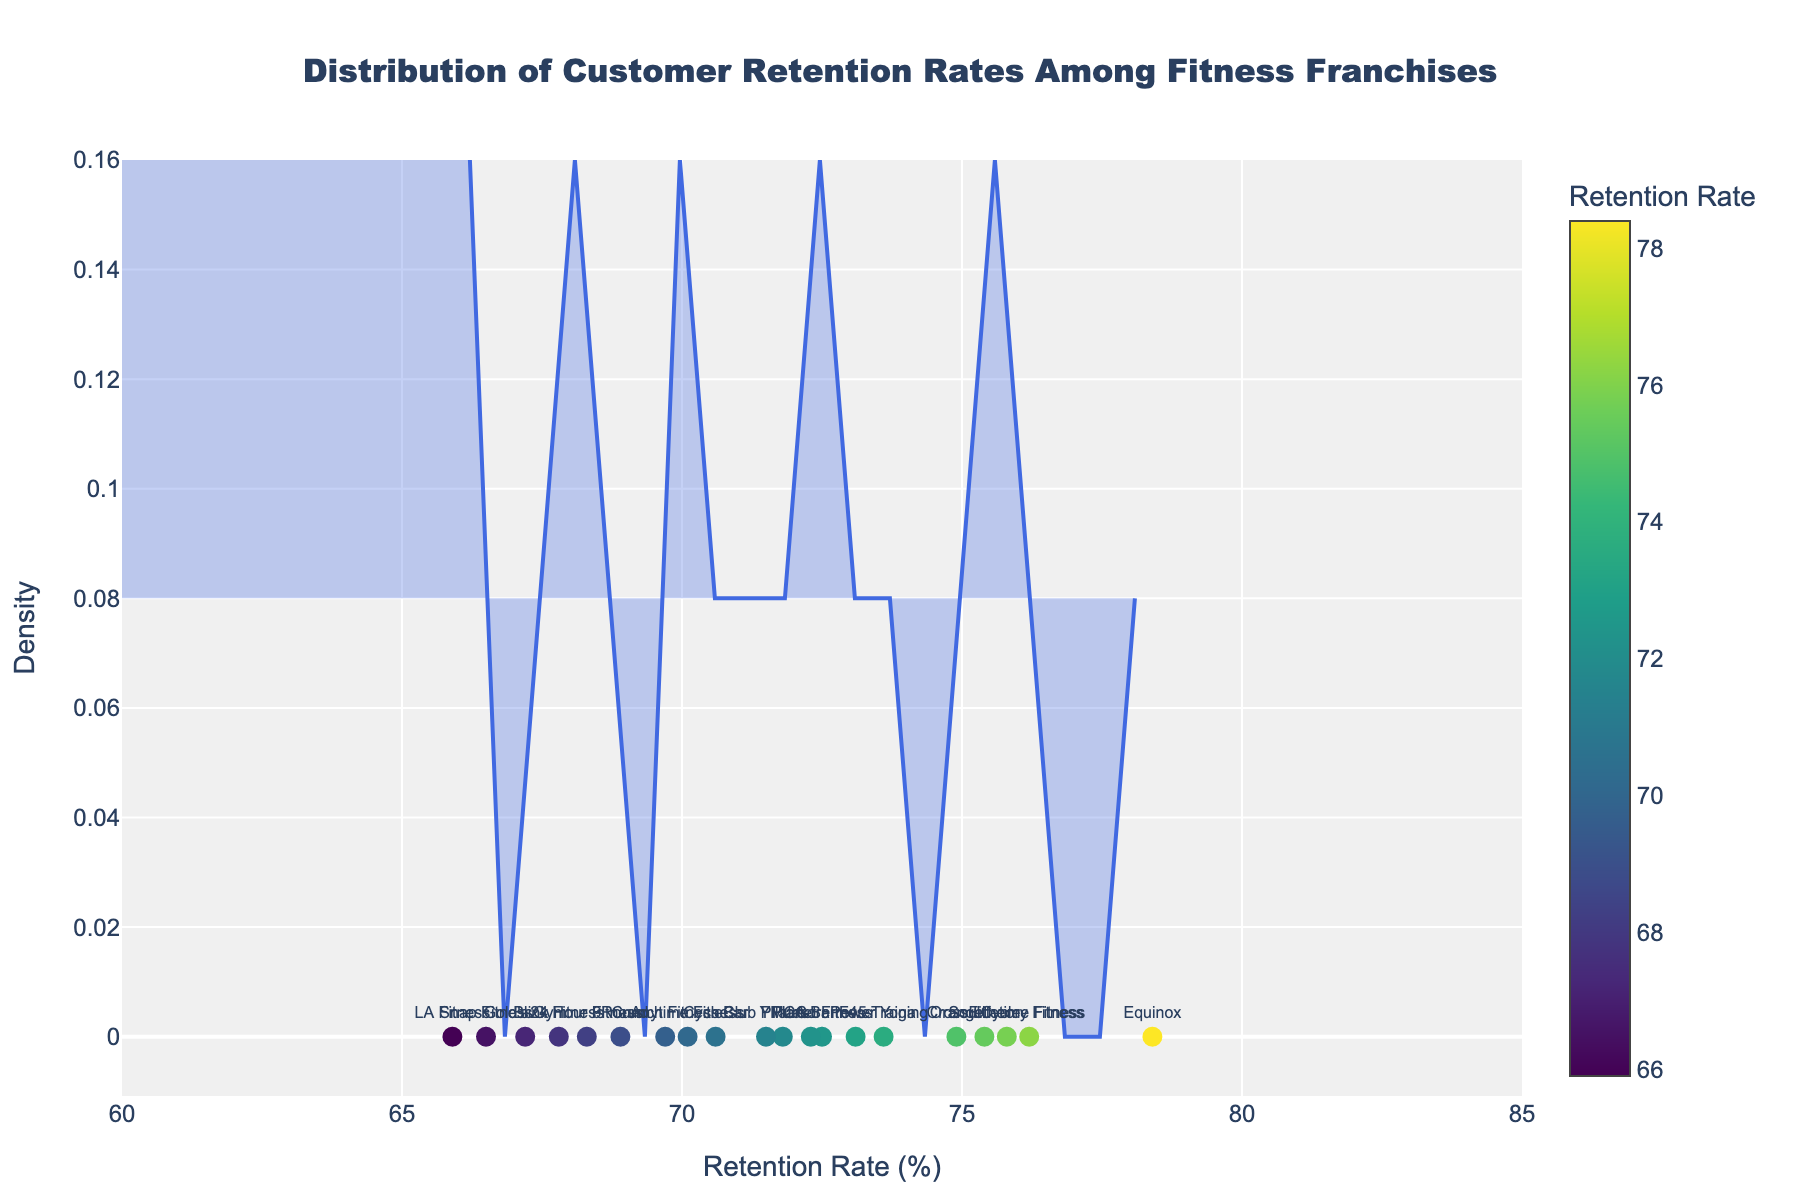What's the title of the plot? The title is displayed at the top of the graph, centered and in bold, stating the main topic or focus of the figure. The text reads: "Distribution of Customer Retention Rates Among Fitness Franchises," indicating it showcases retention rates across various fitness franchises.
Answer: Distribution of Customer Retention Rates Among Fitness Franchises What does the x-axis represent? The x-axis is labeled "Retention Rate (%)" and runs horizontally. It represents the retention rates of different fitness franchises as percentages.
Answer: Retention Rate (%) How many franchises have their retention rates plotted? The scatter plot dots represent individual franchises marked along the x-axis. Each dot is labeled with the franchise name, and there are 20 labels visible.
Answer: 20 What is the retention rate of Equinox? By finding the "Equinox" label directly on the x-axis, you can see that it's located at 78.4%.
Answer: 78.4% Which franchise has the highest retention rate? The franchise with the label furthest to the right on the x-axis has the highest retention rate. "Equinox" is the franchise positioned at 78.4%, making it the highest.
Answer: Equinox How does the retention rate of 24 Hour Fitness compare to that of Blink Fitness? Look at both labels "24 Hour Fitness" and "Blink Fitness" on the x-axis. "24 Hour Fitness" is at 68.3% and "Blink Fitness" is at 67.8%. Thus, "24 Hour Fitness" has a slightly higher retention rate.
Answer: 24 Hour Fitness has a higher retention rate What is the approximate density value at a retention rate of 70%? Along the density curve, locate the x-axis value of 70%. Find the y-value (density) directly above this point. The density looks to be around 0.1, according to the plot.
Answer: Around 0.1 Between what retention rate values does the maximum density occur? The peak of the density curve shows where most data points cluster. Visual examination of the chart shows the peak around x-values of 70-73%.
Answer: 70-73% What is the range of retention rates displayed in the plot? The x-axis spans from a minimum to a maximum retention rate value, visibly extending from 60% to 85% on the figure.
Answer: 60% to 85% Which two franchises have retention rates closest to each other? By visually inspecting the labels on the x-axis, "Club Pilates" (71.5%) and "YMCA" (71.8%) appear nearest to each other in retention rate values.
Answer: Club Pilates and YMCA 